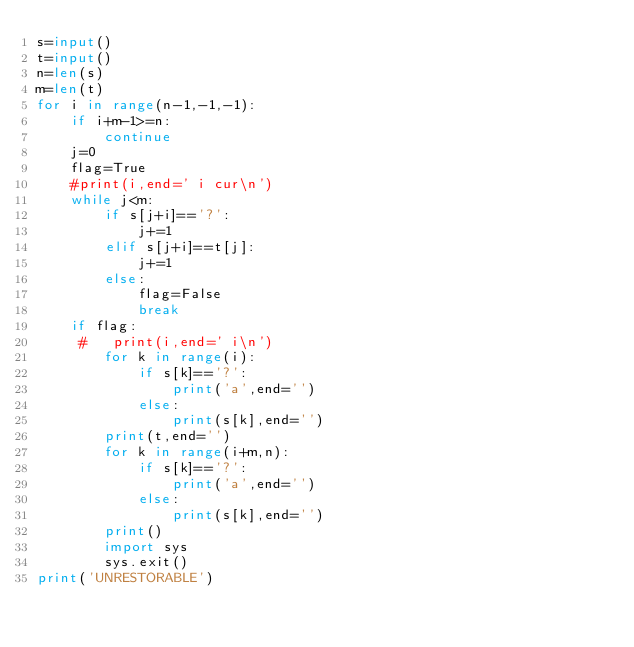<code> <loc_0><loc_0><loc_500><loc_500><_Python_>s=input()
t=input()
n=len(s)
m=len(t)
for i in range(n-1,-1,-1):
    if i+m-1>=n:
        continue
    j=0
    flag=True
    #print(i,end=' i cur\n')
    while j<m:
        if s[j+i]=='?':
            j+=1
        elif s[j+i]==t[j]:
            j+=1
        else:
            flag=False
            break
    if flag:
     #   print(i,end=' i\n')
        for k in range(i):
            if s[k]=='?':
                print('a',end='')
            else:
                print(s[k],end='')
        print(t,end='')
        for k in range(i+m,n):
            if s[k]=='?':
                print('a',end='')
            else:
                print(s[k],end='')
        print()
        import sys
        sys.exit()
print('UNRESTORABLE')

</code> 